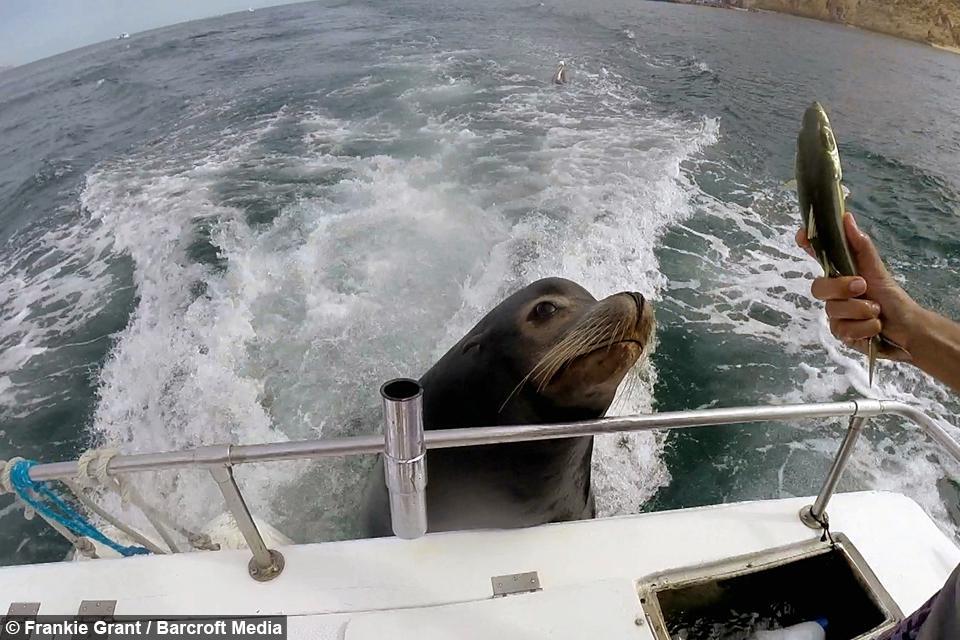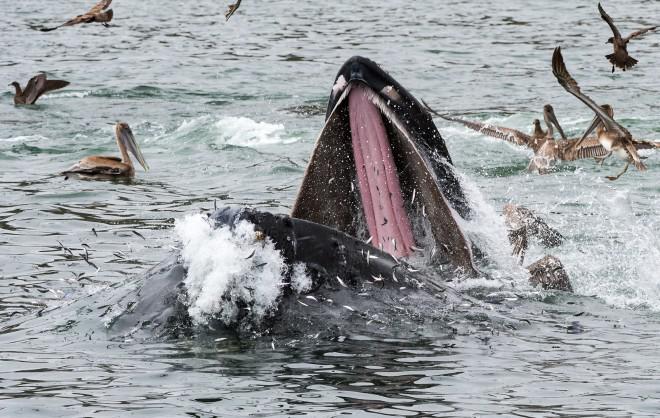The first image is the image on the left, the second image is the image on the right. Considering the images on both sides, is "In one image, there's an aquarist with at least one sea lion." valid? Answer yes or no. No. The first image is the image on the left, the second image is the image on the right. Given the left and right images, does the statement "seals are swimming in a square pool with a tone wall behind them" hold true? Answer yes or no. No. 